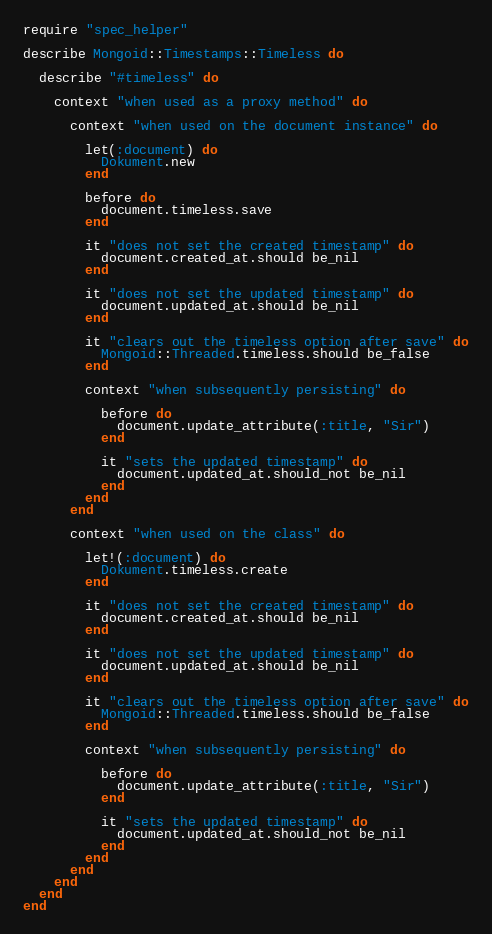Convert code to text. <code><loc_0><loc_0><loc_500><loc_500><_Ruby_>require "spec_helper"

describe Mongoid::Timestamps::Timeless do

  describe "#timeless" do

    context "when used as a proxy method" do

      context "when used on the document instance" do

        let(:document) do
          Dokument.new
        end

        before do
          document.timeless.save
        end

        it "does not set the created timestamp" do
          document.created_at.should be_nil
        end

        it "does not set the updated timestamp" do
          document.updated_at.should be_nil
        end

        it "clears out the timeless option after save" do
          Mongoid::Threaded.timeless.should be_false
        end

        context "when subsequently persisting" do

          before do
            document.update_attribute(:title, "Sir")
          end

          it "sets the updated timestamp" do
            document.updated_at.should_not be_nil
          end
        end
      end

      context "when used on the class" do

        let!(:document) do
          Dokument.timeless.create
        end

        it "does not set the created timestamp" do
          document.created_at.should be_nil
        end

        it "does not set the updated timestamp" do
          document.updated_at.should be_nil
        end

        it "clears out the timeless option after save" do
          Mongoid::Threaded.timeless.should be_false
        end

        context "when subsequently persisting" do

          before do
            document.update_attribute(:title, "Sir")
          end

          it "sets the updated timestamp" do
            document.updated_at.should_not be_nil
          end
        end
      end
    end
  end
end
</code> 